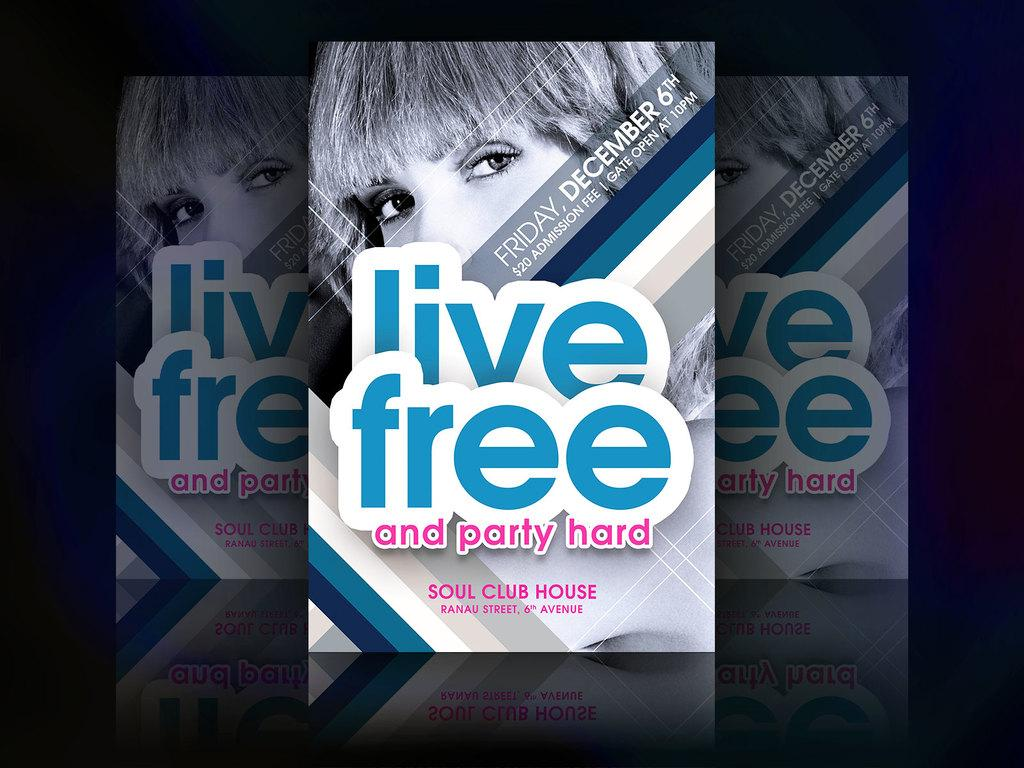<image>
Render a clear and concise summary of the photo. A book cover with A women on the cover advertising her appearance on Friday, December 6th. 